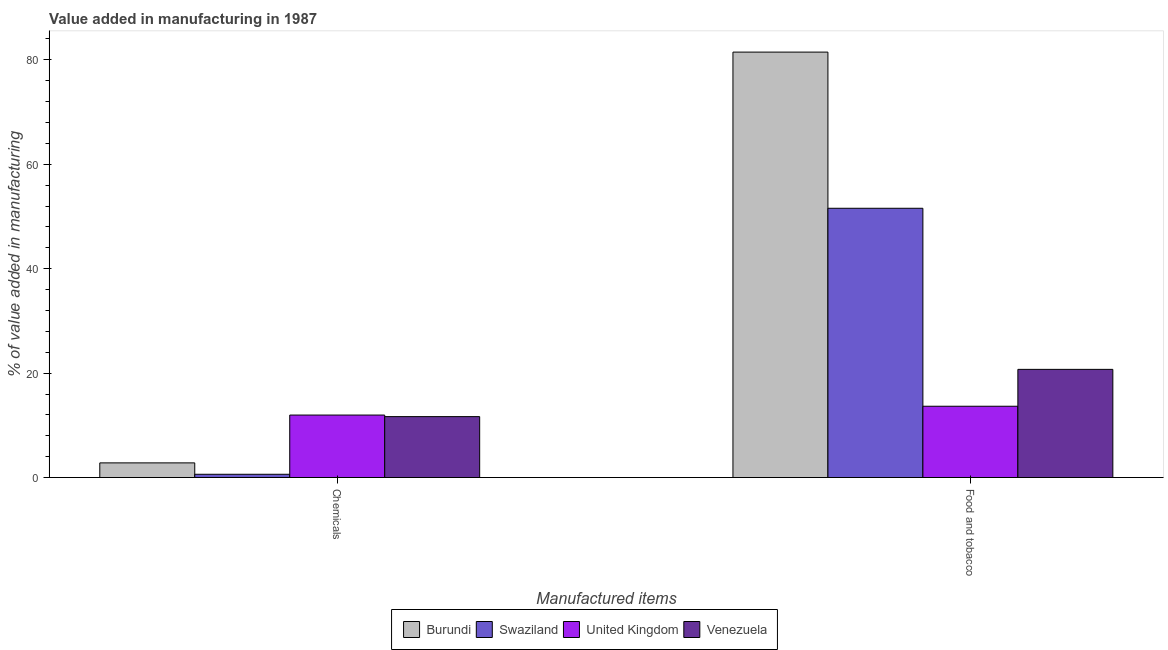How many different coloured bars are there?
Provide a short and direct response. 4. Are the number of bars per tick equal to the number of legend labels?
Provide a succinct answer. Yes. How many bars are there on the 2nd tick from the left?
Provide a succinct answer. 4. How many bars are there on the 1st tick from the right?
Give a very brief answer. 4. What is the label of the 1st group of bars from the left?
Your answer should be very brief. Chemicals. What is the value added by manufacturing food and tobacco in United Kingdom?
Offer a terse response. 13.66. Across all countries, what is the maximum value added by  manufacturing chemicals?
Your response must be concise. 11.97. Across all countries, what is the minimum value added by  manufacturing chemicals?
Your response must be concise. 0.63. In which country was the value added by manufacturing food and tobacco minimum?
Keep it short and to the point. United Kingdom. What is the total value added by manufacturing food and tobacco in the graph?
Your response must be concise. 167.42. What is the difference between the value added by  manufacturing chemicals in Burundi and that in United Kingdom?
Your answer should be very brief. -9.16. What is the difference between the value added by manufacturing food and tobacco in Swaziland and the value added by  manufacturing chemicals in United Kingdom?
Give a very brief answer. 39.6. What is the average value added by manufacturing food and tobacco per country?
Ensure brevity in your answer.  41.86. What is the difference between the value added by  manufacturing chemicals and value added by manufacturing food and tobacco in United Kingdom?
Provide a succinct answer. -1.69. What is the ratio of the value added by manufacturing food and tobacco in Swaziland to that in Venezuela?
Make the answer very short. 2.49. What does the 3rd bar from the left in Chemicals represents?
Make the answer very short. United Kingdom. How many bars are there?
Offer a terse response. 8. What is the difference between two consecutive major ticks on the Y-axis?
Provide a succinct answer. 20. Are the values on the major ticks of Y-axis written in scientific E-notation?
Keep it short and to the point. No. Does the graph contain any zero values?
Keep it short and to the point. No. Does the graph contain grids?
Offer a very short reply. No. Where does the legend appear in the graph?
Make the answer very short. Bottom center. What is the title of the graph?
Provide a succinct answer. Value added in manufacturing in 1987. Does "Indonesia" appear as one of the legend labels in the graph?
Your answer should be compact. No. What is the label or title of the X-axis?
Provide a succinct answer. Manufactured items. What is the label or title of the Y-axis?
Your answer should be compact. % of value added in manufacturing. What is the % of value added in manufacturing of Burundi in Chemicals?
Make the answer very short. 2.81. What is the % of value added in manufacturing of Swaziland in Chemicals?
Provide a short and direct response. 0.63. What is the % of value added in manufacturing of United Kingdom in Chemicals?
Provide a short and direct response. 11.97. What is the % of value added in manufacturing of Venezuela in Chemicals?
Give a very brief answer. 11.67. What is the % of value added in manufacturing of Burundi in Food and tobacco?
Give a very brief answer. 81.48. What is the % of value added in manufacturing of Swaziland in Food and tobacco?
Offer a very short reply. 51.57. What is the % of value added in manufacturing in United Kingdom in Food and tobacco?
Ensure brevity in your answer.  13.66. What is the % of value added in manufacturing in Venezuela in Food and tobacco?
Offer a very short reply. 20.72. Across all Manufactured items, what is the maximum % of value added in manufacturing in Burundi?
Ensure brevity in your answer.  81.48. Across all Manufactured items, what is the maximum % of value added in manufacturing in Swaziland?
Ensure brevity in your answer.  51.57. Across all Manufactured items, what is the maximum % of value added in manufacturing in United Kingdom?
Give a very brief answer. 13.66. Across all Manufactured items, what is the maximum % of value added in manufacturing in Venezuela?
Your answer should be very brief. 20.72. Across all Manufactured items, what is the minimum % of value added in manufacturing of Burundi?
Provide a short and direct response. 2.81. Across all Manufactured items, what is the minimum % of value added in manufacturing in Swaziland?
Ensure brevity in your answer.  0.63. Across all Manufactured items, what is the minimum % of value added in manufacturing in United Kingdom?
Provide a succinct answer. 11.97. Across all Manufactured items, what is the minimum % of value added in manufacturing of Venezuela?
Your response must be concise. 11.67. What is the total % of value added in manufacturing in Burundi in the graph?
Keep it short and to the point. 84.29. What is the total % of value added in manufacturing of Swaziland in the graph?
Provide a short and direct response. 52.2. What is the total % of value added in manufacturing in United Kingdom in the graph?
Provide a short and direct response. 25.63. What is the total % of value added in manufacturing of Venezuela in the graph?
Ensure brevity in your answer.  32.39. What is the difference between the % of value added in manufacturing in Burundi in Chemicals and that in Food and tobacco?
Make the answer very short. -78.67. What is the difference between the % of value added in manufacturing of Swaziland in Chemicals and that in Food and tobacco?
Give a very brief answer. -50.94. What is the difference between the % of value added in manufacturing of United Kingdom in Chemicals and that in Food and tobacco?
Offer a terse response. -1.69. What is the difference between the % of value added in manufacturing of Venezuela in Chemicals and that in Food and tobacco?
Keep it short and to the point. -9.05. What is the difference between the % of value added in manufacturing of Burundi in Chemicals and the % of value added in manufacturing of Swaziland in Food and tobacco?
Offer a very short reply. -48.76. What is the difference between the % of value added in manufacturing in Burundi in Chemicals and the % of value added in manufacturing in United Kingdom in Food and tobacco?
Offer a very short reply. -10.85. What is the difference between the % of value added in manufacturing in Burundi in Chemicals and the % of value added in manufacturing in Venezuela in Food and tobacco?
Make the answer very short. -17.91. What is the difference between the % of value added in manufacturing of Swaziland in Chemicals and the % of value added in manufacturing of United Kingdom in Food and tobacco?
Your answer should be very brief. -13.03. What is the difference between the % of value added in manufacturing in Swaziland in Chemicals and the % of value added in manufacturing in Venezuela in Food and tobacco?
Give a very brief answer. -20.09. What is the difference between the % of value added in manufacturing of United Kingdom in Chemicals and the % of value added in manufacturing of Venezuela in Food and tobacco?
Ensure brevity in your answer.  -8.75. What is the average % of value added in manufacturing of Burundi per Manufactured items?
Provide a succinct answer. 42.14. What is the average % of value added in manufacturing in Swaziland per Manufactured items?
Offer a very short reply. 26.1. What is the average % of value added in manufacturing in United Kingdom per Manufactured items?
Provide a short and direct response. 12.81. What is the average % of value added in manufacturing of Venezuela per Manufactured items?
Your answer should be very brief. 16.19. What is the difference between the % of value added in manufacturing of Burundi and % of value added in manufacturing of Swaziland in Chemicals?
Provide a short and direct response. 2.18. What is the difference between the % of value added in manufacturing of Burundi and % of value added in manufacturing of United Kingdom in Chemicals?
Offer a very short reply. -9.16. What is the difference between the % of value added in manufacturing of Burundi and % of value added in manufacturing of Venezuela in Chemicals?
Offer a terse response. -8.86. What is the difference between the % of value added in manufacturing of Swaziland and % of value added in manufacturing of United Kingdom in Chemicals?
Ensure brevity in your answer.  -11.34. What is the difference between the % of value added in manufacturing of Swaziland and % of value added in manufacturing of Venezuela in Chemicals?
Your response must be concise. -11.04. What is the difference between the % of value added in manufacturing in United Kingdom and % of value added in manufacturing in Venezuela in Chemicals?
Your answer should be compact. 0.3. What is the difference between the % of value added in manufacturing of Burundi and % of value added in manufacturing of Swaziland in Food and tobacco?
Ensure brevity in your answer.  29.91. What is the difference between the % of value added in manufacturing of Burundi and % of value added in manufacturing of United Kingdom in Food and tobacco?
Ensure brevity in your answer.  67.82. What is the difference between the % of value added in manufacturing in Burundi and % of value added in manufacturing in Venezuela in Food and tobacco?
Your answer should be compact. 60.76. What is the difference between the % of value added in manufacturing of Swaziland and % of value added in manufacturing of United Kingdom in Food and tobacco?
Keep it short and to the point. 37.91. What is the difference between the % of value added in manufacturing in Swaziland and % of value added in manufacturing in Venezuela in Food and tobacco?
Ensure brevity in your answer.  30.85. What is the difference between the % of value added in manufacturing of United Kingdom and % of value added in manufacturing of Venezuela in Food and tobacco?
Provide a succinct answer. -7.06. What is the ratio of the % of value added in manufacturing in Burundi in Chemicals to that in Food and tobacco?
Give a very brief answer. 0.03. What is the ratio of the % of value added in manufacturing of Swaziland in Chemicals to that in Food and tobacco?
Provide a short and direct response. 0.01. What is the ratio of the % of value added in manufacturing in United Kingdom in Chemicals to that in Food and tobacco?
Give a very brief answer. 0.88. What is the ratio of the % of value added in manufacturing in Venezuela in Chemicals to that in Food and tobacco?
Your answer should be compact. 0.56. What is the difference between the highest and the second highest % of value added in manufacturing of Burundi?
Provide a short and direct response. 78.67. What is the difference between the highest and the second highest % of value added in manufacturing in Swaziland?
Offer a very short reply. 50.94. What is the difference between the highest and the second highest % of value added in manufacturing in United Kingdom?
Give a very brief answer. 1.69. What is the difference between the highest and the second highest % of value added in manufacturing of Venezuela?
Your response must be concise. 9.05. What is the difference between the highest and the lowest % of value added in manufacturing of Burundi?
Offer a very short reply. 78.67. What is the difference between the highest and the lowest % of value added in manufacturing in Swaziland?
Ensure brevity in your answer.  50.94. What is the difference between the highest and the lowest % of value added in manufacturing of United Kingdom?
Offer a very short reply. 1.69. What is the difference between the highest and the lowest % of value added in manufacturing of Venezuela?
Provide a short and direct response. 9.05. 